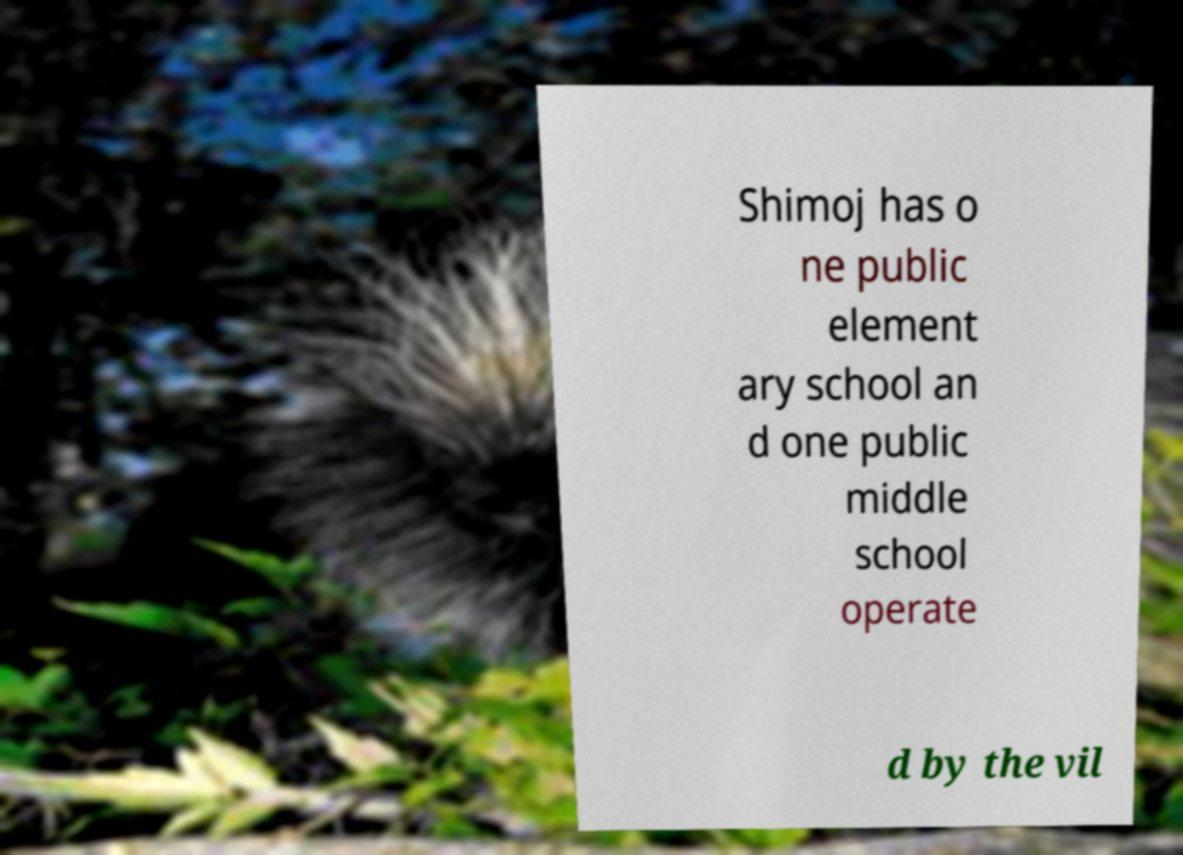Please read and relay the text visible in this image. What does it say? Shimoj has o ne public element ary school an d one public middle school operate d by the vil 